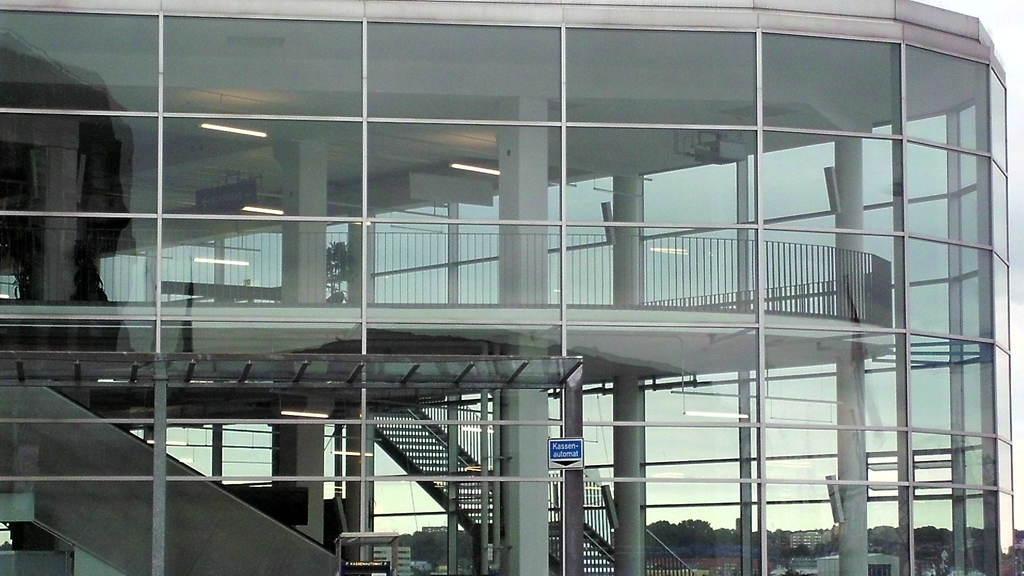Describe this image in one or two sentences. On the right side of the image we can see a glass building and elevator. In the middle of his image we can see a glass building, steps and a plant. On the right side of the image we can see a glass building and some trees. 